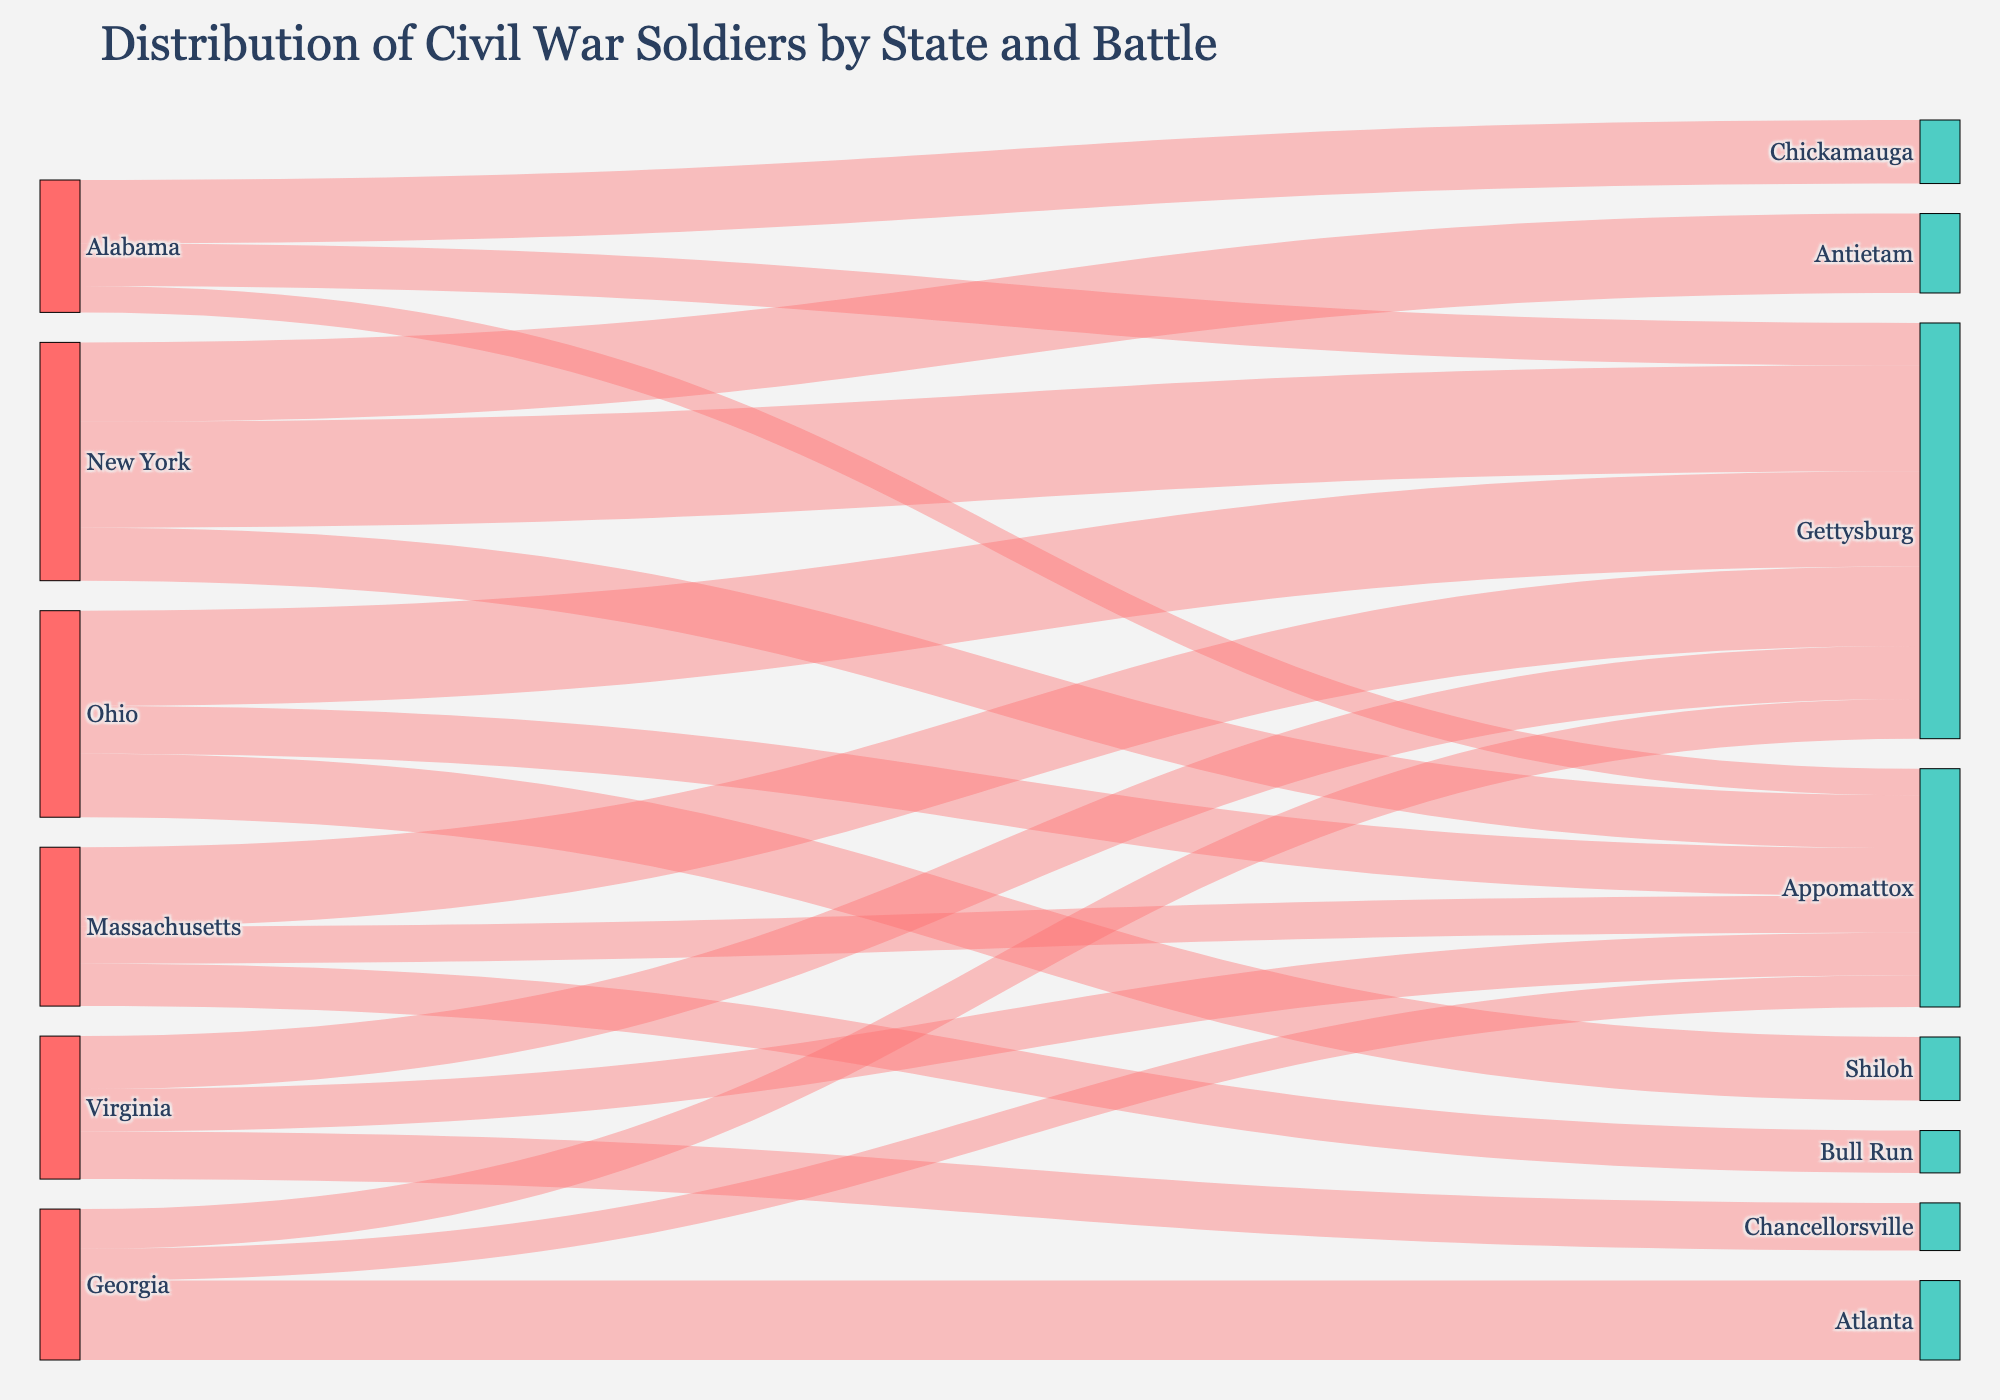What's the title of the Sankey Diagram? The title is usually found at the top center of the figure. By reading the top center text, we can identify the title of the Sankey Diagram.
Answer: Distribution of Civil War Soldiers by State and Battle How many soldiers from Alabama fought at Gettysburg? The Sankey Diagram provides a direct link between "Alabama" and "Gettysburg." By examining this link and reading the value associated with it, we can determine the number of soldiers.
Answer: 8000 Which state contributed the most soldiers to the battle of Gettysburg? To find this, we examine all the links going to "Gettysburg" and compare their values. The state with the highest value in these links is the one that contributed the most soldiers.
Answer: New York How many total soldiers from Alabama fought in all battles represented in the Sankey Diagram? Sum the values of all the links originating from "Alabama" to their respective battle locations.
Answer: 8000 + 12000 + 5000 = 25000 Which state had the highest number of soldiers ending up at Appomattox? Compare the values of the links directed towards "Appomattox" from different states. The state with the highest value is the one that contributed the most soldiers to Appomattox.
Answer: Ohio Compare the number of soldiers from Georgia and Virginia that ended up at Appomattox. Which state had more soldiers there? Look at the values of the links from "Georgia" to "Appomattox" and from "Virginia" to "Appomattox". Compare these two values.
Answer: Virginia had more soldiers What's the total number of soldiers represented in the entire Sankey Diagram? Sum all the values from all the links represented in the Sankey Diagram.
Answer: 8000 + 12000 + 5000 + 7500 + 15000 + 6000 + 10000 + 9000 + 8000 + 20000 + 15000 + 10000 + 18000 + 12000 + 9000 + 15000 + 8000 + 7000 = 210500 Which battle exclusively received soldiers from New York and no other state? Identify the target nodes (battles) that have only one link coming from "New York" and ensure no other states connect to these battles.
Answer: Antietam How many states are represented in the Sankey Diagram? By counting the number of unique source labels (states) in the diagram, we can determine the total number of states represented.
Answer: 5 Which battle had the second-highest number of soldiers from Ohio? Identify the two battles connected to Ohio and compare their values to determine which battle had the second-highest number.
Answer: Appomattox 